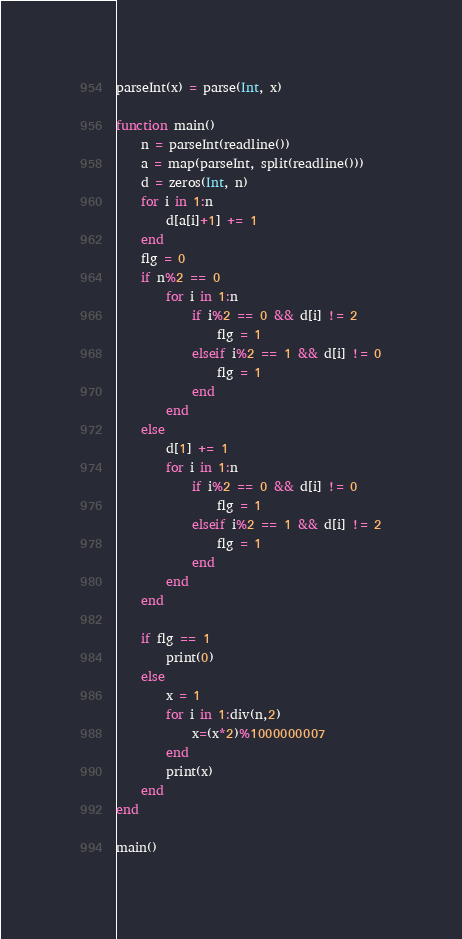Convert code to text. <code><loc_0><loc_0><loc_500><loc_500><_Julia_>parseInt(x) = parse(Int, x)

function main()
	n = parseInt(readline())
	a = map(parseInt, split(readline()))
	d = zeros(Int, n)
	for i in 1:n
		d[a[i]+1] += 1
	end
	flg = 0
	if n%2 == 0
		for i in 1:n
			if i%2 == 0 && d[i] != 2
				flg = 1
			elseif i%2 == 1 && d[i] != 0
				flg = 1
			end
		end
	else
		d[1] += 1
		for i in 1:n
			if i%2 == 0 && d[i] != 0
				flg = 1
			elseif i%2 == 1 && d[i] != 2
				flg = 1
			end
		end
	end
    
	if flg == 1
		print(0)
	else
		x = 1
		for i in 1:div(n,2)
			x=(x*2)%1000000007
		end
		print(x)
	end
end

main()</code> 